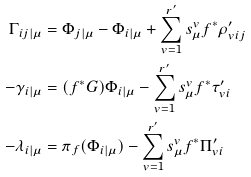<formula> <loc_0><loc_0><loc_500><loc_500>\Gamma _ { i j | \mu } & = \Phi _ { j | \mu } - \Phi _ { i | \mu } + \sum _ { v = 1 } ^ { r ^ { \prime } } s _ { \mu } ^ { v } f ^ { * } \rho _ { v i j } ^ { \prime } \\ - \gamma _ { i | \mu } & = ( f ^ { * } G ) \Phi _ { i | \mu } - \sum _ { v = 1 } ^ { r ^ { \prime } } s _ { \mu } ^ { v } f ^ { * } \tau _ { v i } ^ { \prime } \\ - \lambda _ { i | \mu } & = \pi _ { f } ( \Phi _ { i | \mu } ) - \sum _ { v = 1 } ^ { r ^ { \prime } } s _ { \mu } ^ { v } f ^ { * } \Pi _ { v i } ^ { \prime }</formula> 